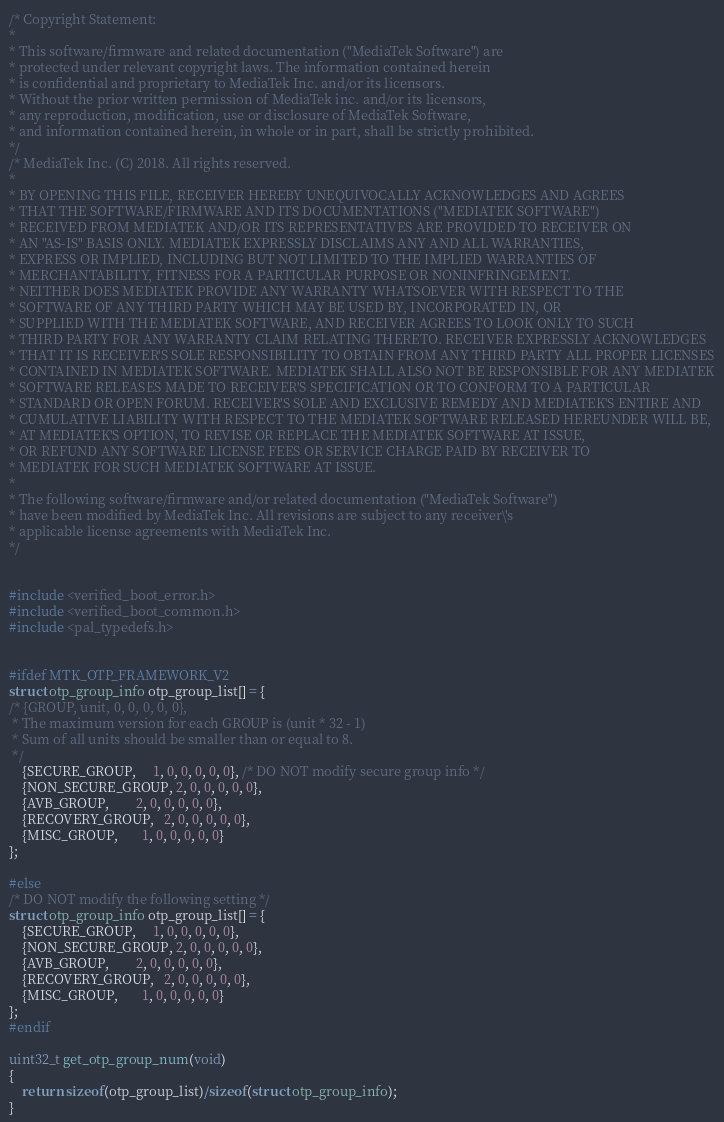<code> <loc_0><loc_0><loc_500><loc_500><_C_>/* Copyright Statement:
*
* This software/firmware and related documentation ("MediaTek Software") are
* protected under relevant copyright laws. The information contained herein
* is confidential and proprietary to MediaTek Inc. and/or its licensors.
* Without the prior written permission of MediaTek inc. and/or its licensors,
* any reproduction, modification, use or disclosure of MediaTek Software,
* and information contained herein, in whole or in part, shall be strictly prohibited.
*/
/* MediaTek Inc. (C) 2018. All rights reserved.
*
* BY OPENING THIS FILE, RECEIVER HEREBY UNEQUIVOCALLY ACKNOWLEDGES AND AGREES
* THAT THE SOFTWARE/FIRMWARE AND ITS DOCUMENTATIONS ("MEDIATEK SOFTWARE")
* RECEIVED FROM MEDIATEK AND/OR ITS REPRESENTATIVES ARE PROVIDED TO RECEIVER ON
* AN "AS-IS" BASIS ONLY. MEDIATEK EXPRESSLY DISCLAIMS ANY AND ALL WARRANTIES,
* EXPRESS OR IMPLIED, INCLUDING BUT NOT LIMITED TO THE IMPLIED WARRANTIES OF
* MERCHANTABILITY, FITNESS FOR A PARTICULAR PURPOSE OR NONINFRINGEMENT.
* NEITHER DOES MEDIATEK PROVIDE ANY WARRANTY WHATSOEVER WITH RESPECT TO THE
* SOFTWARE OF ANY THIRD PARTY WHICH MAY BE USED BY, INCORPORATED IN, OR
* SUPPLIED WITH THE MEDIATEK SOFTWARE, AND RECEIVER AGREES TO LOOK ONLY TO SUCH
* THIRD PARTY FOR ANY WARRANTY CLAIM RELATING THERETO. RECEIVER EXPRESSLY ACKNOWLEDGES
* THAT IT IS RECEIVER'S SOLE RESPONSIBILITY TO OBTAIN FROM ANY THIRD PARTY ALL PROPER LICENSES
* CONTAINED IN MEDIATEK SOFTWARE. MEDIATEK SHALL ALSO NOT BE RESPONSIBLE FOR ANY MEDIATEK
* SOFTWARE RELEASES MADE TO RECEIVER'S SPECIFICATION OR TO CONFORM TO A PARTICULAR
* STANDARD OR OPEN FORUM. RECEIVER'S SOLE AND EXCLUSIVE REMEDY AND MEDIATEK'S ENTIRE AND
* CUMULATIVE LIABILITY WITH RESPECT TO THE MEDIATEK SOFTWARE RELEASED HEREUNDER WILL BE,
* AT MEDIATEK'S OPTION, TO REVISE OR REPLACE THE MEDIATEK SOFTWARE AT ISSUE,
* OR REFUND ANY SOFTWARE LICENSE FEES OR SERVICE CHARGE PAID BY RECEIVER TO
* MEDIATEK FOR SUCH MEDIATEK SOFTWARE AT ISSUE.
*
* The following software/firmware and/or related documentation ("MediaTek Software")
* have been modified by MediaTek Inc. All revisions are subject to any receiver\'s
* applicable license agreements with MediaTek Inc.
*/


#include <verified_boot_error.h>
#include <verified_boot_common.h>
#include <pal_typedefs.h>


#ifdef MTK_OTP_FRAMEWORK_V2
struct otp_group_info otp_group_list[] = {
/* {GROUP, unit, 0, 0, 0, 0, 0},
 * The maximum version for each GROUP is (unit * 32 - 1)
 * Sum of all units should be smaller than or equal to 8.
 */
	{SECURE_GROUP,     1, 0, 0, 0, 0, 0}, /* DO NOT modify secure group info */
	{NON_SECURE_GROUP, 2, 0, 0, 0, 0, 0},
	{AVB_GROUP,        2, 0, 0, 0, 0, 0},
	{RECOVERY_GROUP,   2, 0, 0, 0, 0, 0},
	{MISC_GROUP,       1, 0, 0, 0, 0, 0}
};

#else
/* DO NOT modify the following setting */
struct otp_group_info otp_group_list[] = {
	{SECURE_GROUP,     1, 0, 0, 0, 0, 0},
	{NON_SECURE_GROUP, 2, 0, 0, 0, 0, 0},
	{AVB_GROUP,        2, 0, 0, 0, 0, 0},
	{RECOVERY_GROUP,   2, 0, 0, 0, 0, 0},
	{MISC_GROUP,       1, 0, 0, 0, 0, 0}
};
#endif

uint32_t get_otp_group_num(void)
{
	return sizeof(otp_group_list)/sizeof(struct otp_group_info);
}

</code> 